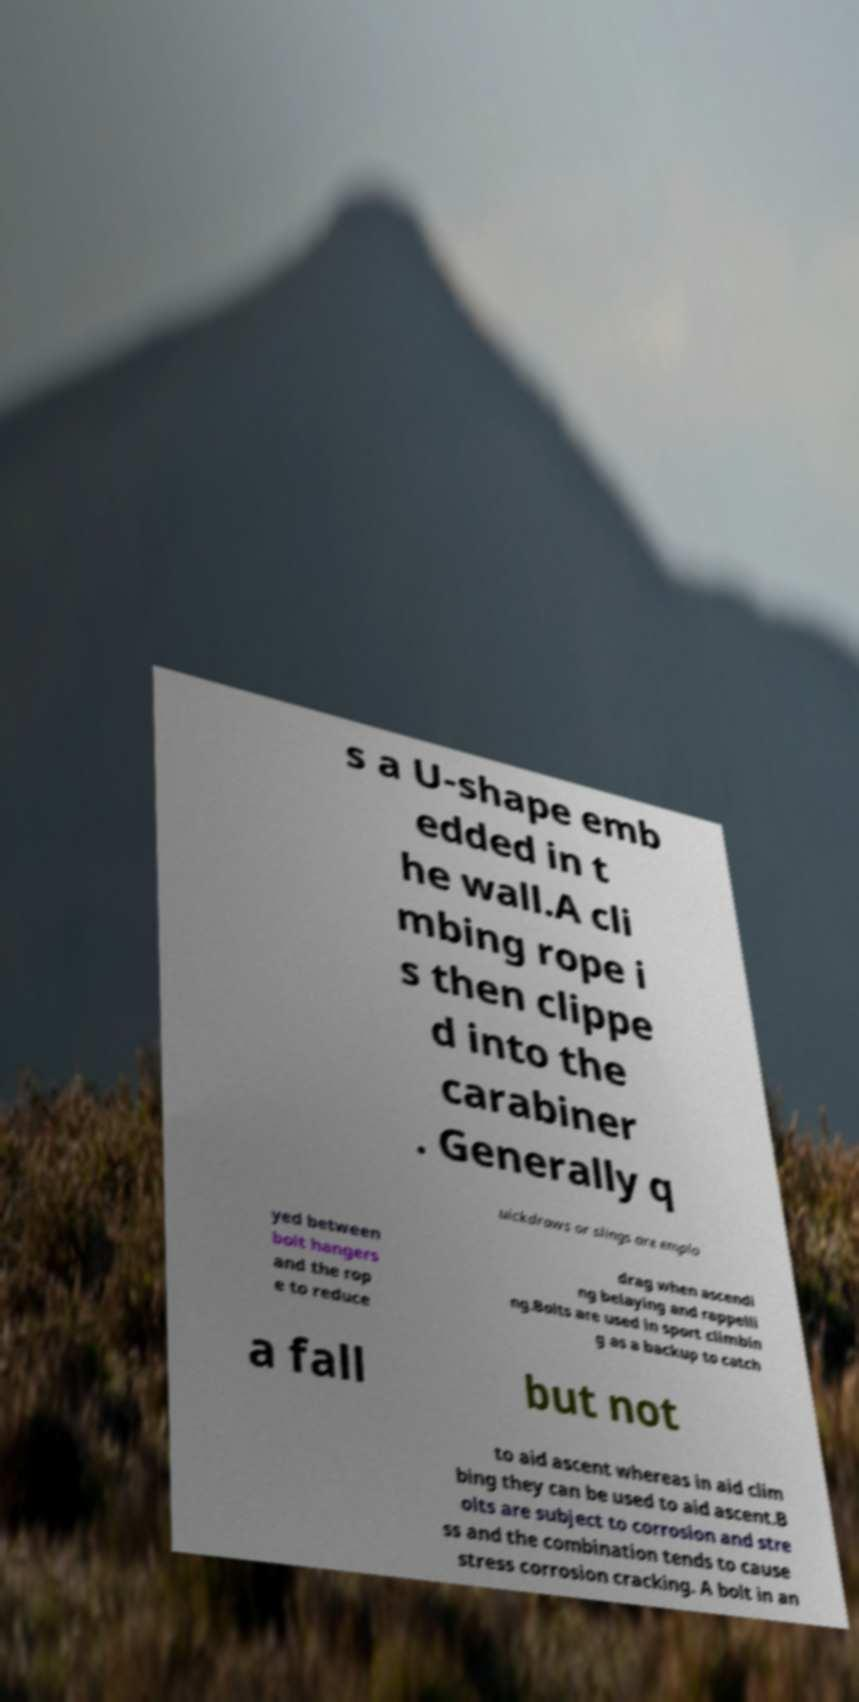Please read and relay the text visible in this image. What does it say? s a U-shape emb edded in t he wall.A cli mbing rope i s then clippe d into the carabiner . Generally q uickdraws or slings are emplo yed between bolt hangers and the rop e to reduce drag when ascendi ng belaying and rappelli ng.Bolts are used in sport climbin g as a backup to catch a fall but not to aid ascent whereas in aid clim bing they can be used to aid ascent.B olts are subject to corrosion and stre ss and the combination tends to cause stress corrosion cracking. A bolt in an 